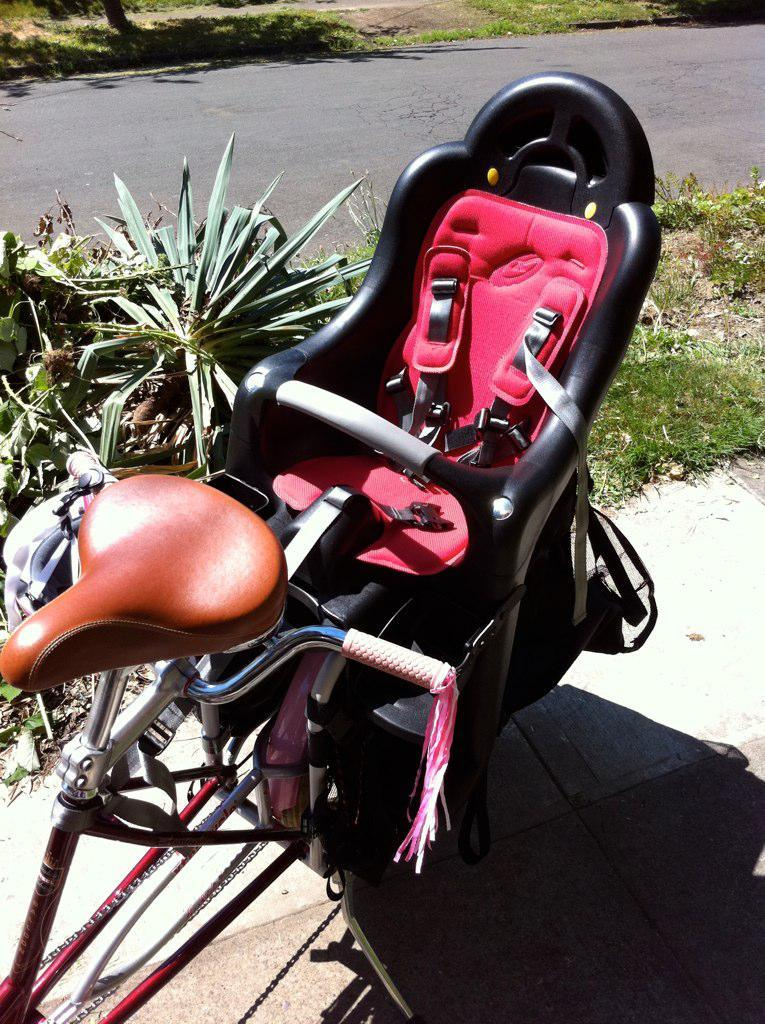What is the color of the seat on the bicycle in the image? The seat is black and pink in color. What is the seat placed on in the image? The seat is placed on a bicycle. What other objects can be seen in the image besides the bicycle? There are small plants visible in the image. What type of surface is visible in the image? There is a road in the image. What type of song is being played by the eye in the image? There is no eye or song present in the image. 